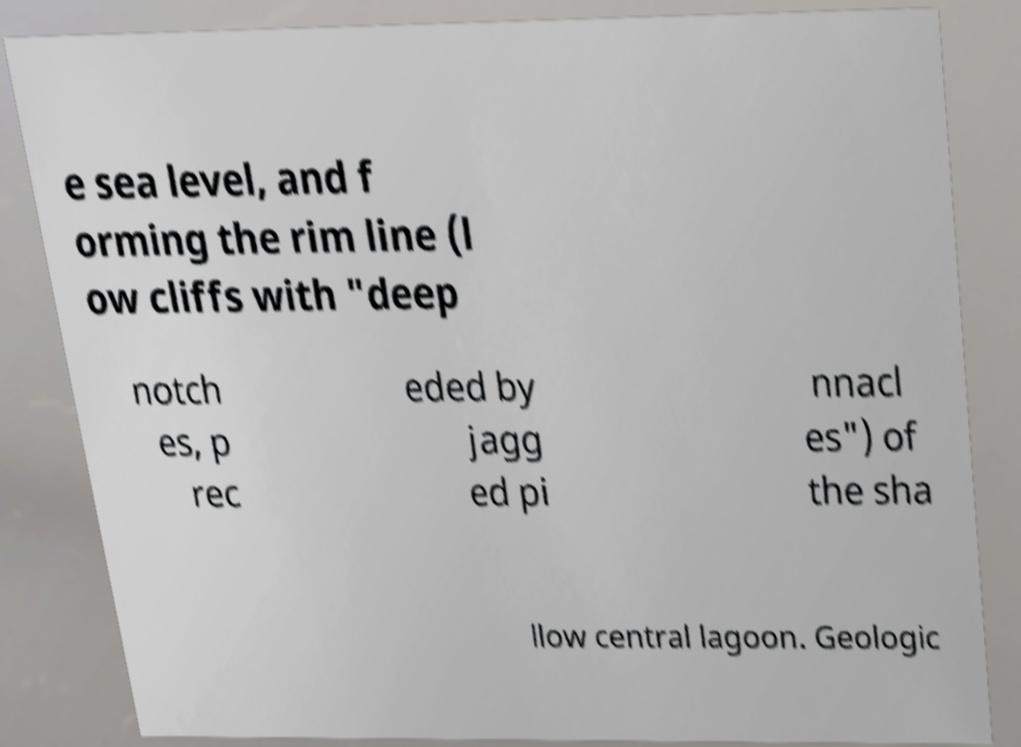For documentation purposes, I need the text within this image transcribed. Could you provide that? e sea level, and f orming the rim line (l ow cliffs with "deep notch es, p rec eded by jagg ed pi nnacl es") of the sha llow central lagoon. Geologic 